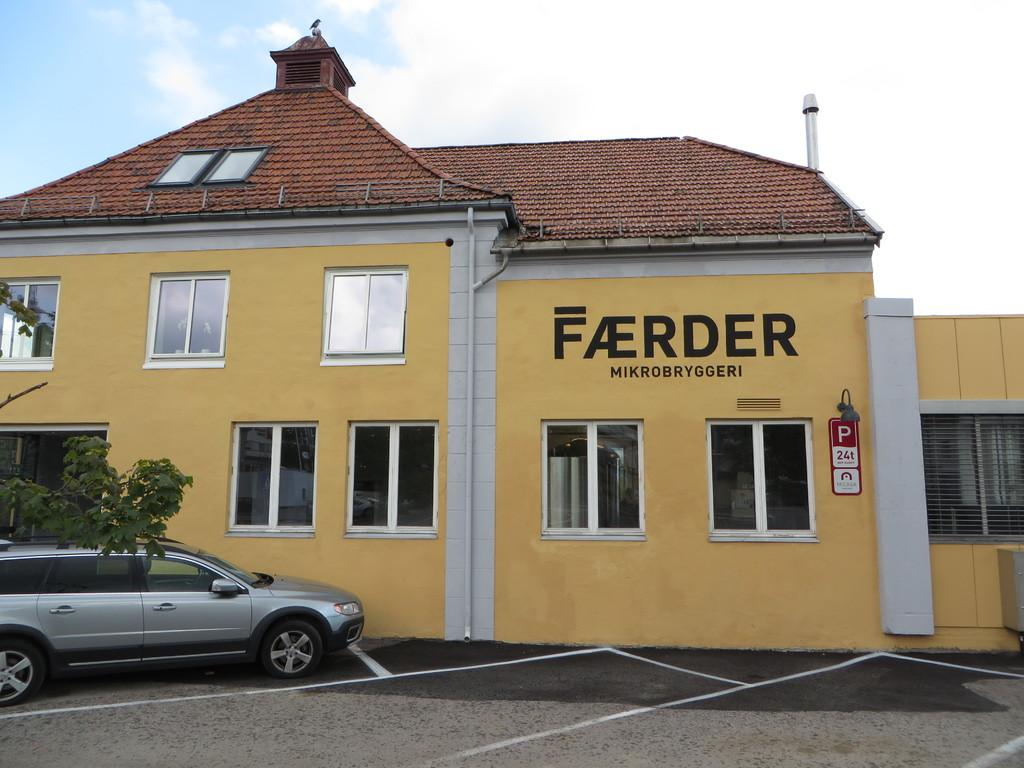What is the main subject in the foreground of the image? There is a car in the foreground of the image. Where is the car located? The car is on the road. What else can be seen in the foreground of the image? There is a tree in the foreground of the image. What type of structure is visible in the image? There is a building in the image. What feature of the building can be observed? The building has windows. What is visible in the background of the image? The sky is visible in the image. What can be inferred about the weather during the time the image was taken? The image was taken during a sunny day. How many toes are visible on the art piece in the image? There is no art piece or toes present in the image. 